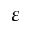<formula> <loc_0><loc_0><loc_500><loc_500>\varepsilon</formula> 